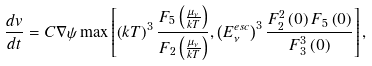<formula> <loc_0><loc_0><loc_500><loc_500>\frac { d v } { d t } = C \nabla \psi \max \left [ \left ( k T \right ) ^ { 3 } \frac { F _ { 5 } \left ( \frac { \mu _ { \nu } } { k T } \right ) } { F _ { 2 } \left ( \frac { \mu _ { \nu } } { k T } \right ) } , \left ( E _ { \nu } ^ { e s c } \right ) ^ { 3 } \frac { F _ { 2 } ^ { 2 } \left ( 0 \right ) F _ { 5 } \left ( 0 \right ) } { F _ { 3 } ^ { 3 } \left ( 0 \right ) } \right ] ,</formula> 